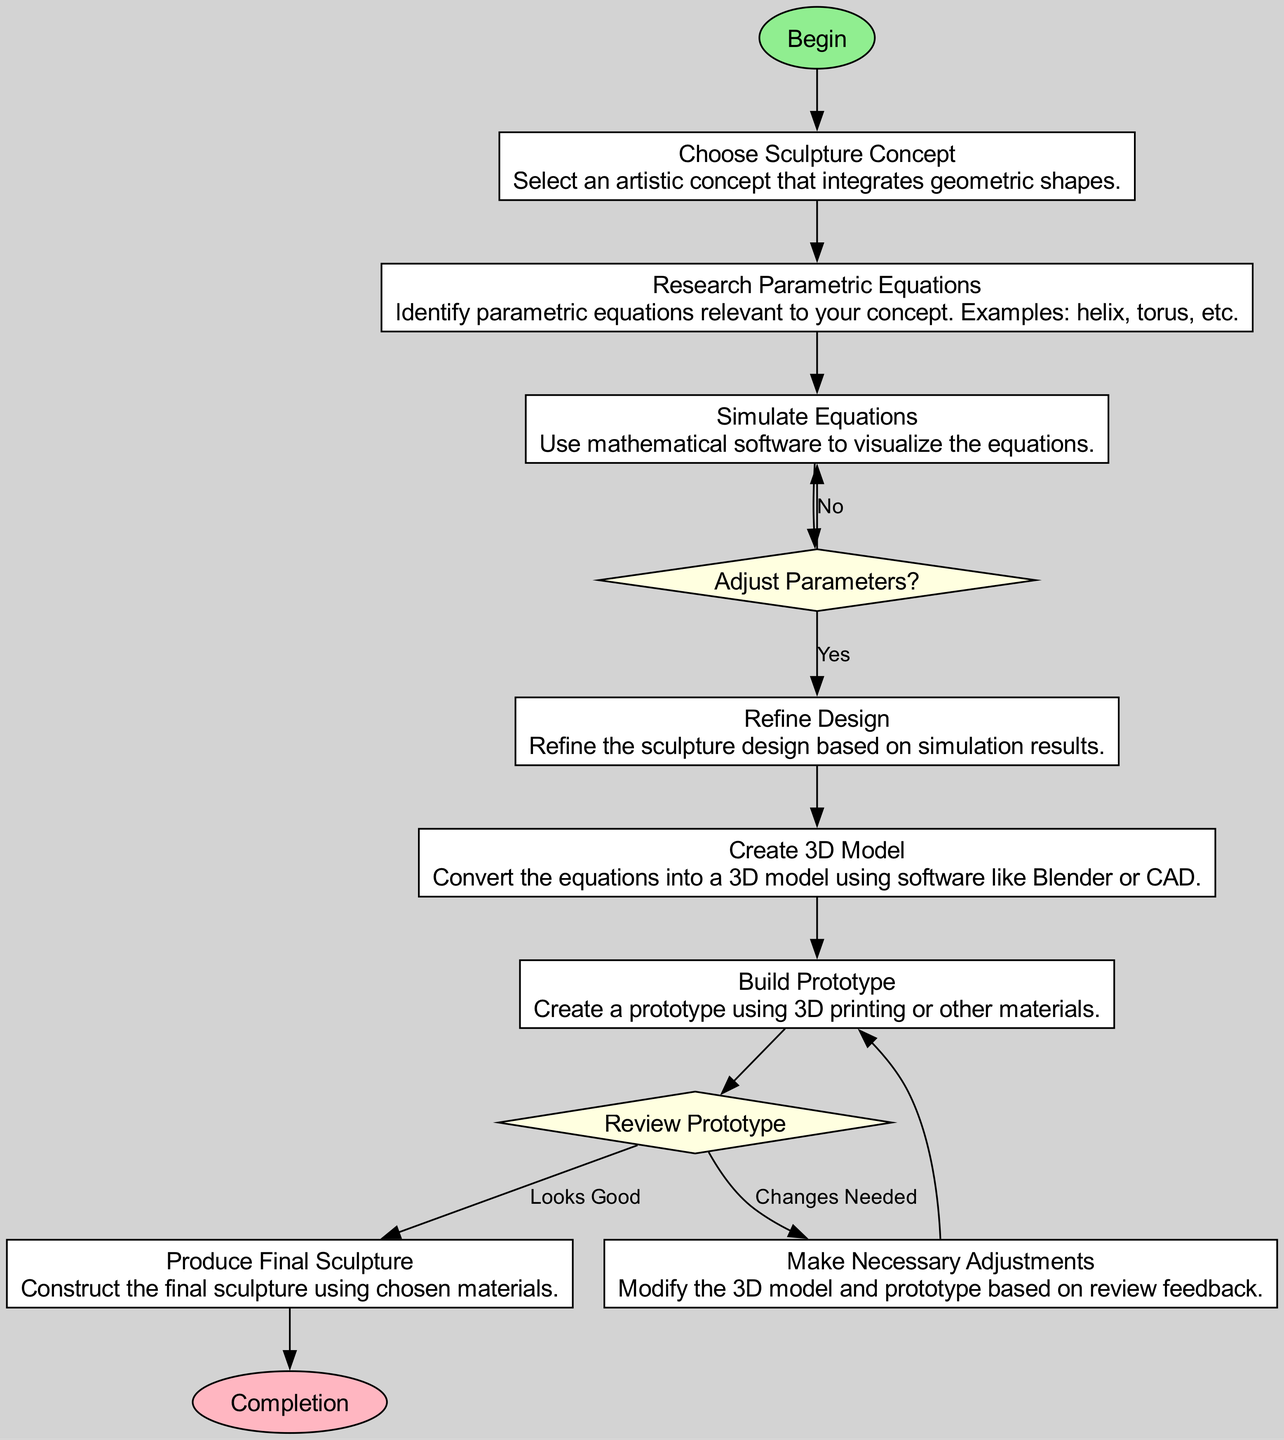What is the first step in the process? The diagram indicates the first step is labeled "Begin". This is part of the flow chart type, which shows a starting point for the entire process.
Answer: Begin How many nodes are there in total? By counting the elements in the flow chart, there are twelve nodes, including the start and end nodes.
Answer: Twelve What is the shape of the "Review Prototype" node? In the flow chart, the "Review Prototype" node is shaped like a diamond, which corresponds to decision points in flow charts.
Answer: Diamond What happens after the "Create 3D Model" step? The diagram shows that after the "Create 3D Model," the next step is to "Build Prototype," as indicated by the connection from one node to the next.
Answer: Build Prototype If adjustments are not needed after the "Review Prototype," what is the next step? The flow chart indicates that if everything is satisfactory ("Looks Good"), then the next step is to "Produce Final Sculpture". Therefore, the flow transitions from the review to production.
Answer: Produce Final Sculpture What kind of decisions are involved in "Adjust Parameters"? The decision involved in "Adjust Parameters" allows for a choice: if parameters need adjusting, one proceeds to "Refine Design"; otherwise, the flow loops back to "Simulate Equations." This showcases a binary decision-making process.
Answer: Binary decision How does "Make Necessary Adjustments" relate to the "Review Prototype"? From the "Review Prototype," the flow leads to "Make Necessary Adjustments" if changes are needed, showcasing the iterative process of refining the sculpture based on evaluations.
Answer: Iterative refinement Which node follows "Simulate Equations"? The flow chart specifies that after "Simulate Equations," the next action is to make a decision at "Adjust Parameters," creating a direct connection from one to the other.
Answer: Adjust Parameters What is the final output of the process? The flow chart concludes with the "Completion" node, indicating the end of the process after producing the final sculpture.
Answer: Completion 